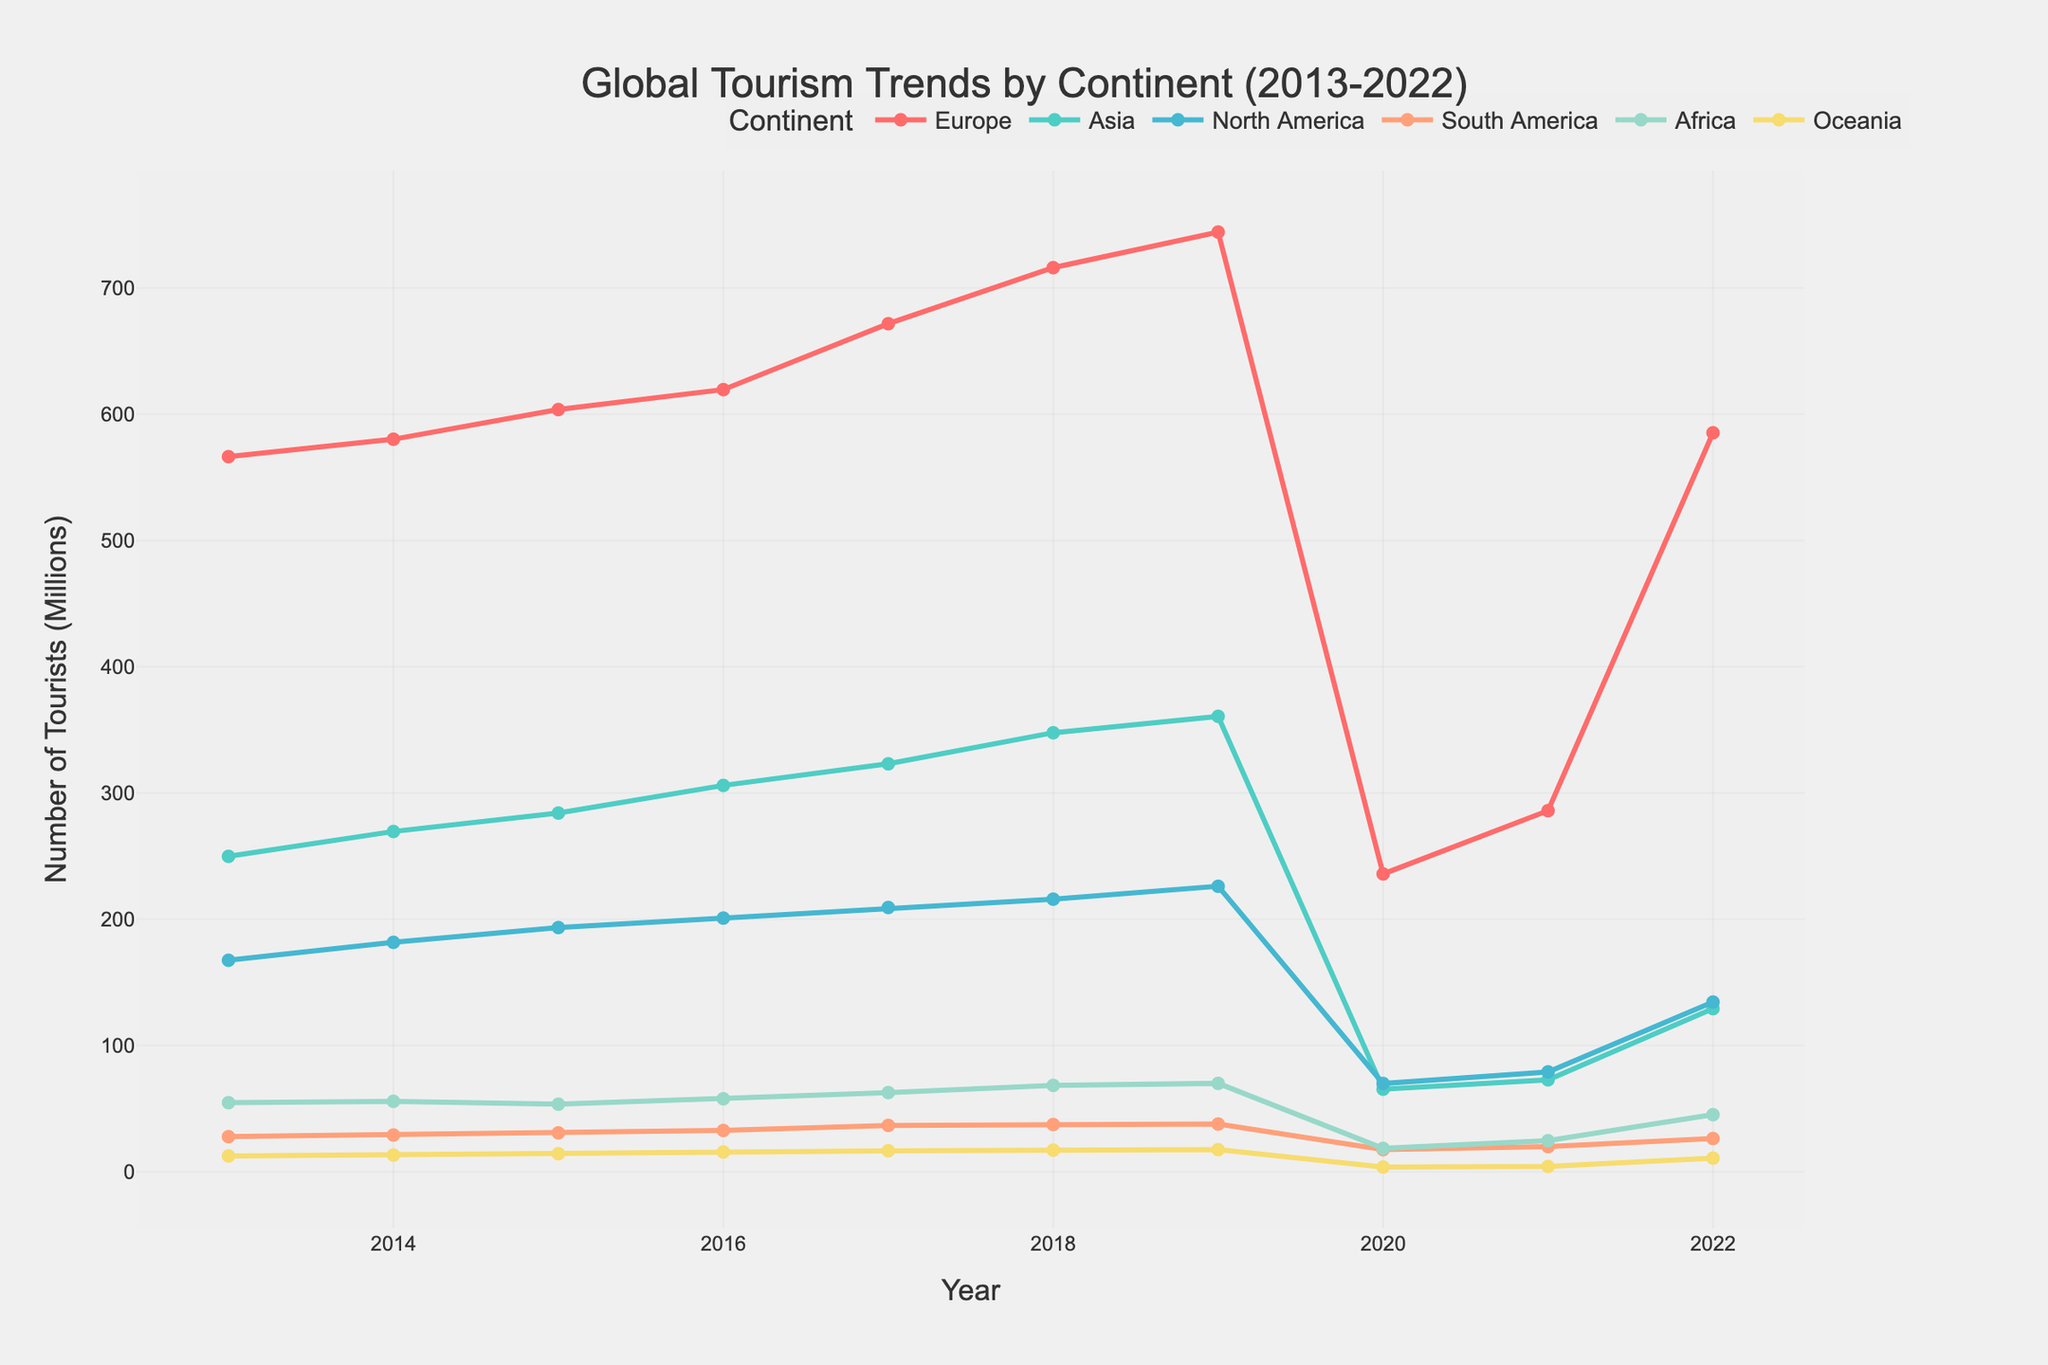What was the peak value for Europe, and in which year did it occur? The highest point for Europe is visible in 2019, just before the drastic drop in 2020
Answer: 744.3 million in 2019 Which continent experienced the sharpest decline in tourism numbers from 2019 to 2020? Comparing the lines, we see that Europe has the steepest drop between 2019 and 2020, falling from 744.3 million to 235.9 million tourists
Answer: Europe Did Asia experience greater growth in tourism before the pandemic (2013-2019) or recovery after the pandemic (2020-2022)? For the period 2013 to 2019, Asia's increase was from 249.8 million to 360.7 million, a growth of 110.9 million; from 2020 to 2022, it increased from 65.4 million to 129.2 million, a growth of 63.8 million
Answer: Before the pandemic How did North America's tourism numbers change from 2013 to 2022? In 2013, North America had 167.5 million tourists, and by 2022 it had grown to 134.4 million, but it experienced a peak of 226.1 million in 2019
Answer: Increased by 134.4 million with a significant fluctuation Which two continents showed the least fluctuation in tourism number changes over the past decade? By examining the lines, Oceania and South America display the least fluctuations compared to other continents with relatively small variances.
Answer: Oceania and South America Which continent had the smallest tourist numbers in 2021, and how many tourists did it have? By observing the line chart closely, Oceania has the lower number with 4.2 million tourists in 2021
Answer: Oceania with 4.2 million tourists By how much did tourism in Africa change from its lowest point during the pandemic to 2022? From the figure, Africa's lowest point during the pandemic was 18.5 million in 2020, rising to 45.2 million in 2022, resulting in an increase of 26.7 million
Answer: Increased by 26.7 million What was the trend in South America’s tourism numbers between 2017 and 2019? The graph shows a very subtle increase going from 36.7 million in 2017 to 37.8 million in 2019
Answer: Slight increase 